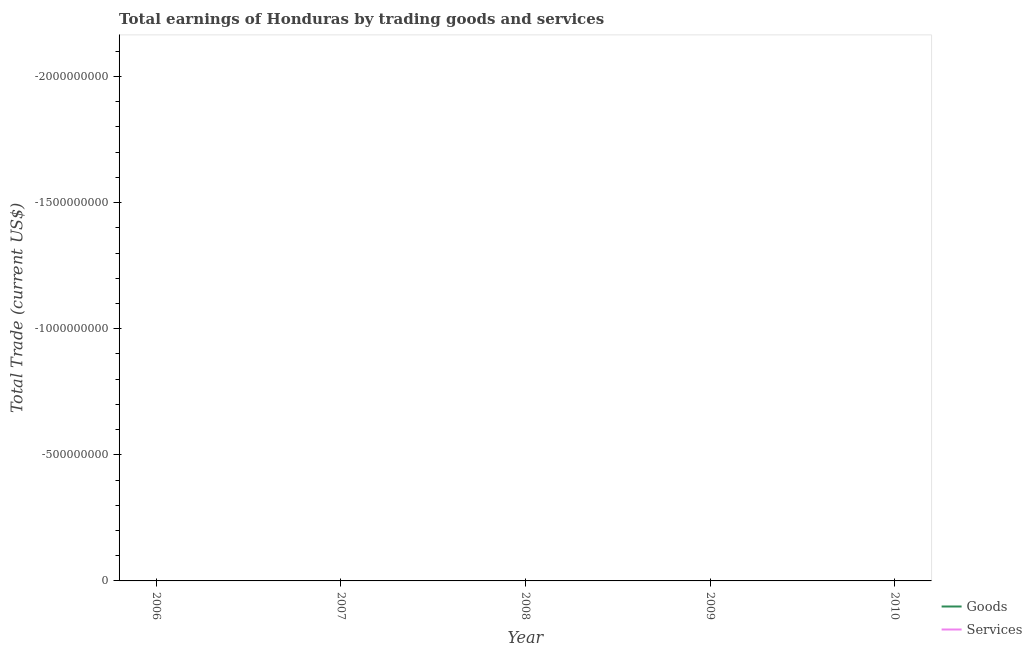How many different coloured lines are there?
Your answer should be compact. 0. Is the number of lines equal to the number of legend labels?
Provide a short and direct response. No. What is the amount earned by trading services in 2010?
Provide a succinct answer. 0. Across all years, what is the minimum amount earned by trading services?
Your response must be concise. 0. What is the total amount earned by trading services in the graph?
Provide a short and direct response. 0. What is the difference between the amount earned by trading services in 2009 and the amount earned by trading goods in 2007?
Give a very brief answer. 0. What is the average amount earned by trading goods per year?
Provide a succinct answer. 0. In how many years, is the amount earned by trading services greater than -1000000000 US$?
Your answer should be very brief. 0. In how many years, is the amount earned by trading goods greater than the average amount earned by trading goods taken over all years?
Keep it short and to the point. 0. Is the amount earned by trading services strictly greater than the amount earned by trading goods over the years?
Provide a succinct answer. Yes. Is the amount earned by trading services strictly less than the amount earned by trading goods over the years?
Your answer should be very brief. No. How many lines are there?
Provide a succinct answer. 0. How many years are there in the graph?
Offer a very short reply. 5. What is the difference between two consecutive major ticks on the Y-axis?
Keep it short and to the point. 5.00e+08. Does the graph contain any zero values?
Provide a short and direct response. Yes. Where does the legend appear in the graph?
Offer a very short reply. Bottom right. How are the legend labels stacked?
Ensure brevity in your answer.  Vertical. What is the title of the graph?
Provide a short and direct response. Total earnings of Honduras by trading goods and services. Does "Drinking water services" appear as one of the legend labels in the graph?
Your response must be concise. No. What is the label or title of the Y-axis?
Keep it short and to the point. Total Trade (current US$). What is the Total Trade (current US$) in Goods in 2007?
Make the answer very short. 0. What is the Total Trade (current US$) in Services in 2009?
Offer a very short reply. 0. What is the Total Trade (current US$) in Goods in 2010?
Make the answer very short. 0. What is the total Total Trade (current US$) of Goods in the graph?
Make the answer very short. 0. 